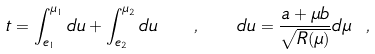<formula> <loc_0><loc_0><loc_500><loc_500>t = \int _ { e _ { 1 } } ^ { \mu _ { 1 } } d u + \int _ { e _ { 2 } } ^ { \mu _ { 2 } } d u \quad , \quad d u = \frac { a + \mu b } { \sqrt { R ( \mu ) } } d \mu \ ,</formula> 